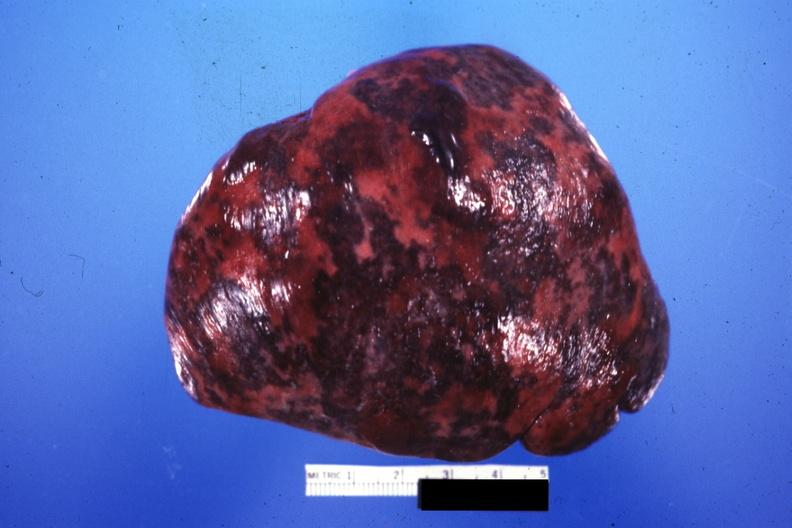s coronary artery present?
Answer the question using a single word or phrase. No 